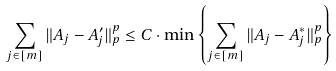Convert formula to latex. <formula><loc_0><loc_0><loc_500><loc_500>\sum _ { j \in [ m ] } { \| A _ { j } - A _ { j } ^ { \prime } \| _ { p } ^ { p } } \leq C \cdot \min \left \{ \sum _ { j \in [ m ] } { \| A _ { j } - A _ { j } ^ { * } \| _ { p } ^ { p } } \right \}</formula> 